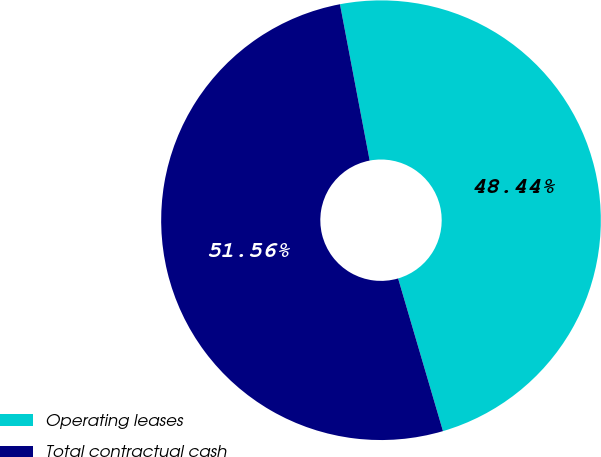Convert chart. <chart><loc_0><loc_0><loc_500><loc_500><pie_chart><fcel>Operating leases<fcel>Total contractual cash<nl><fcel>48.44%<fcel>51.56%<nl></chart> 